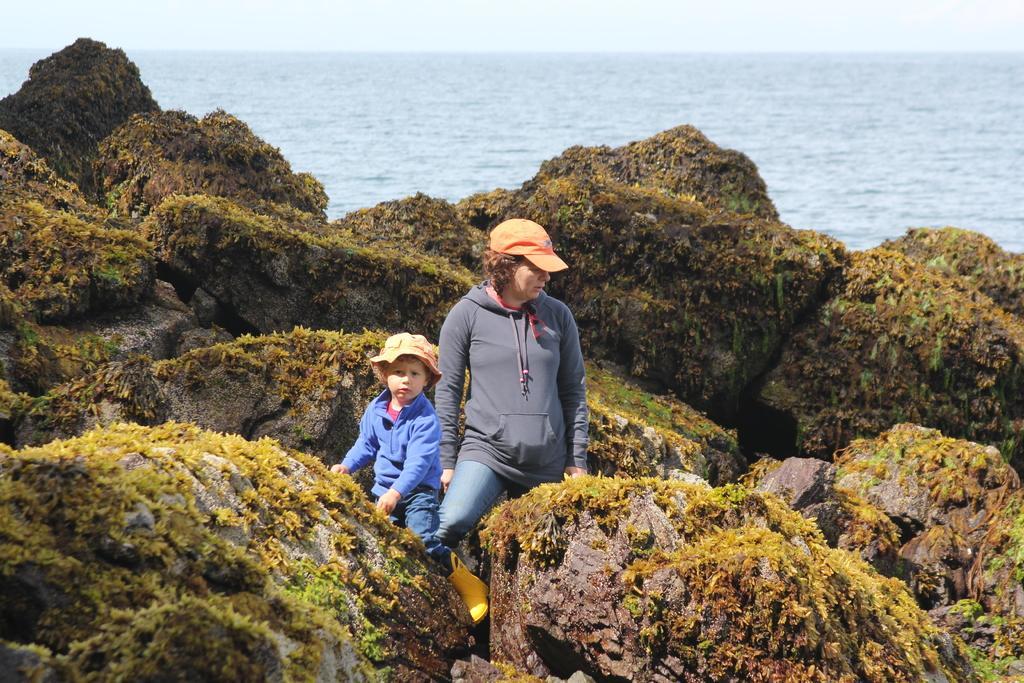How would you summarize this image in a sentence or two? In this image there are rocks, grass and people in the foreground. There is water in the background. And there is a sky at the top. 